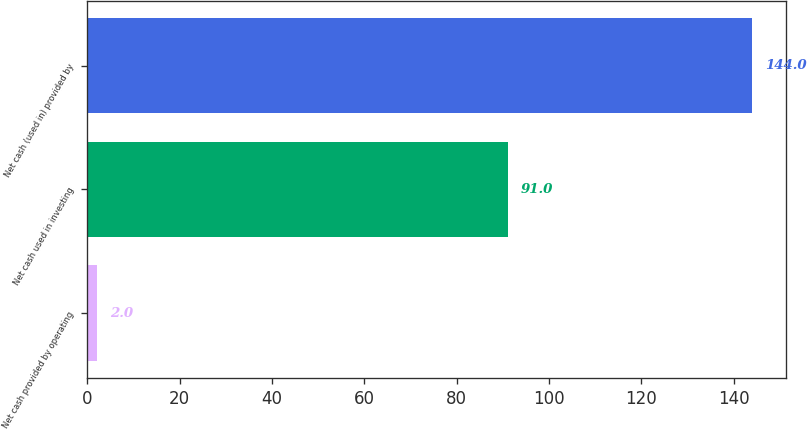Convert chart to OTSL. <chart><loc_0><loc_0><loc_500><loc_500><bar_chart><fcel>Net cash provided by operating<fcel>Net cash used in investing<fcel>Net cash (used in) provided by<nl><fcel>2<fcel>91<fcel>144<nl></chart> 